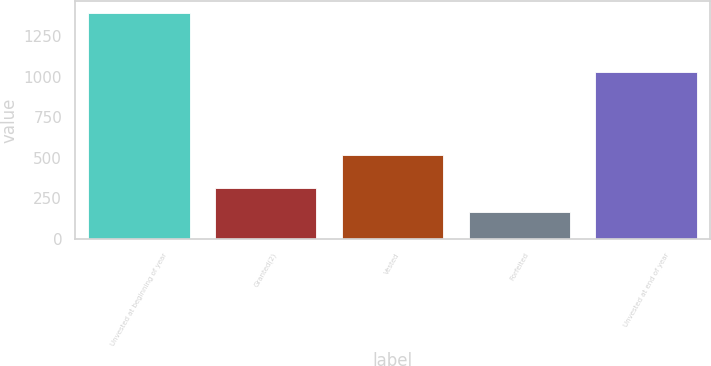<chart> <loc_0><loc_0><loc_500><loc_500><bar_chart><fcel>Unvested at beginning of year<fcel>Granted(2)<fcel>Vested<fcel>Forfeited<fcel>Unvested at end of year<nl><fcel>1394<fcel>315<fcel>519<fcel>164<fcel>1026<nl></chart> 